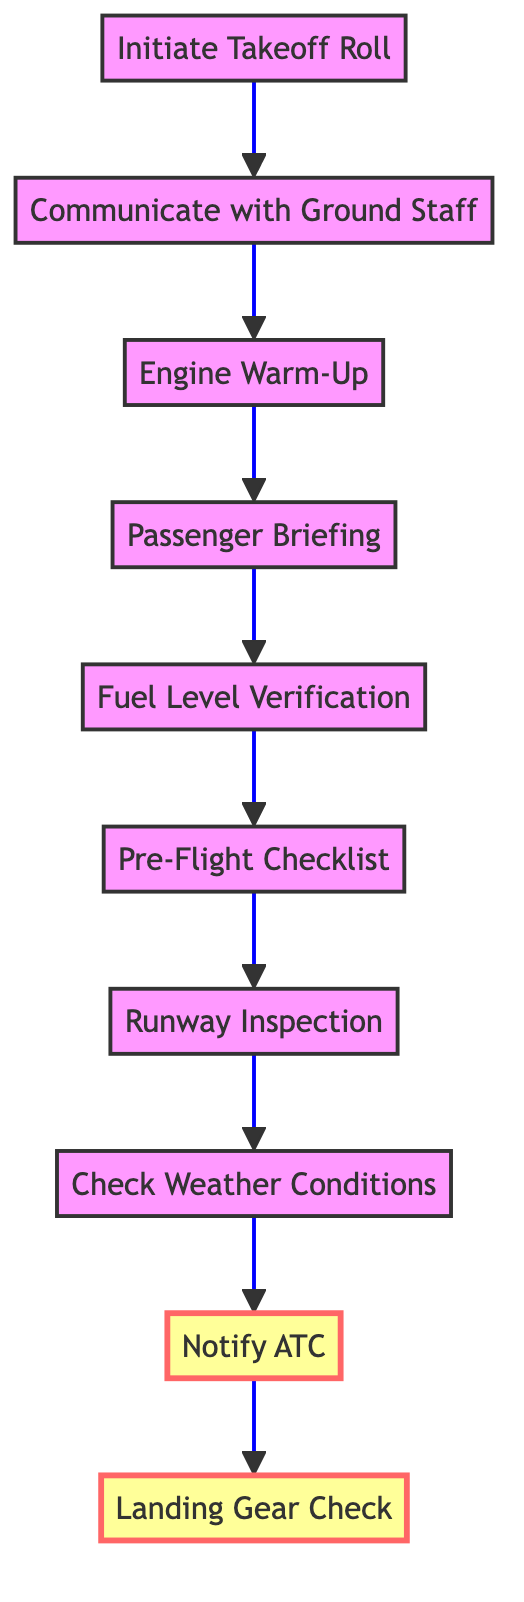What is the final step in the flow diagram? The flow diagram ends with the "Landing Gear Check" step, which is located at the top of the diagram.
Answer: Landing Gear Check How many steps are there in the diagram? Counting each element in the diagram from "Initiate Takeoff Roll" to "Landing Gear Check," there are a total of ten steps.
Answer: Ten What node comes immediately after "Communicate with Ground Staff"? After "Communicate with Ground Staff," the next step in the diagram is "Engine Warm-Up," which follows it directly.
Answer: Engine Warm-Up Which step comes before "Pre-Flight Checklist"? The step that comes before "Pre-Flight Checklist" is "Fuel Level Verification," indicating the order of operations in the sequence.
Answer: Fuel Level Verification What unique aspect is indicated by the highlighted nodes in the diagram? The highlighted nodes "Notify ATC" and "Landing Gear Check" emphasize critical actions for safety before takeoff and after landing.
Answer: Notify ATC and Landing Gear Check How does "Check Weather Conditions" relate to "Notify ATC"? "Check Weather Conditions" must be completed before "Notify ATC," indicating that understanding weather is essential before informing Air Traffic Control.
Answer: Before Notify ATC What is the purpose of the "Passenger Briefing" step? "Passenger Briefing" is included to ensure that passengers are informed of safety procedures and specifics related to the unique destination.
Answer: Inform passengers Which step occurs directly before "Initiate Takeoff Roll"? "Communicate with Ground Staff" occurs directly before "Initiate Takeoff Roll," allowing for coordination before takeoff.
Answer: Communicate with Ground Staff Explain the significance of the order of steps in this diagram. The order in the diagram is crucial for ensuring safety and preparedness. Each step relies on the successful completion of the previous one, leading to a systematic approach for safe takeoff and landing at unique destinations. This logical flow minimizes risks associated with aviation operations.
Answer: Ensures safety and preparedness 